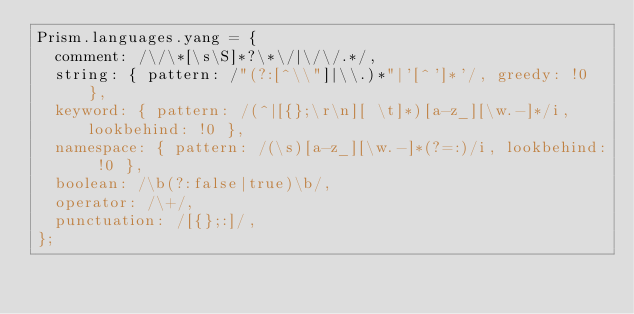<code> <loc_0><loc_0><loc_500><loc_500><_JavaScript_>Prism.languages.yang = {
  comment: /\/\*[\s\S]*?\*\/|\/\/.*/,
  string: { pattern: /"(?:[^\\"]|\\.)*"|'[^']*'/, greedy: !0 },
  keyword: { pattern: /(^|[{};\r\n][ \t]*)[a-z_][\w.-]*/i, lookbehind: !0 },
  namespace: { pattern: /(\s)[a-z_][\w.-]*(?=:)/i, lookbehind: !0 },
  boolean: /\b(?:false|true)\b/,
  operator: /\+/,
  punctuation: /[{};:]/,
};
</code> 